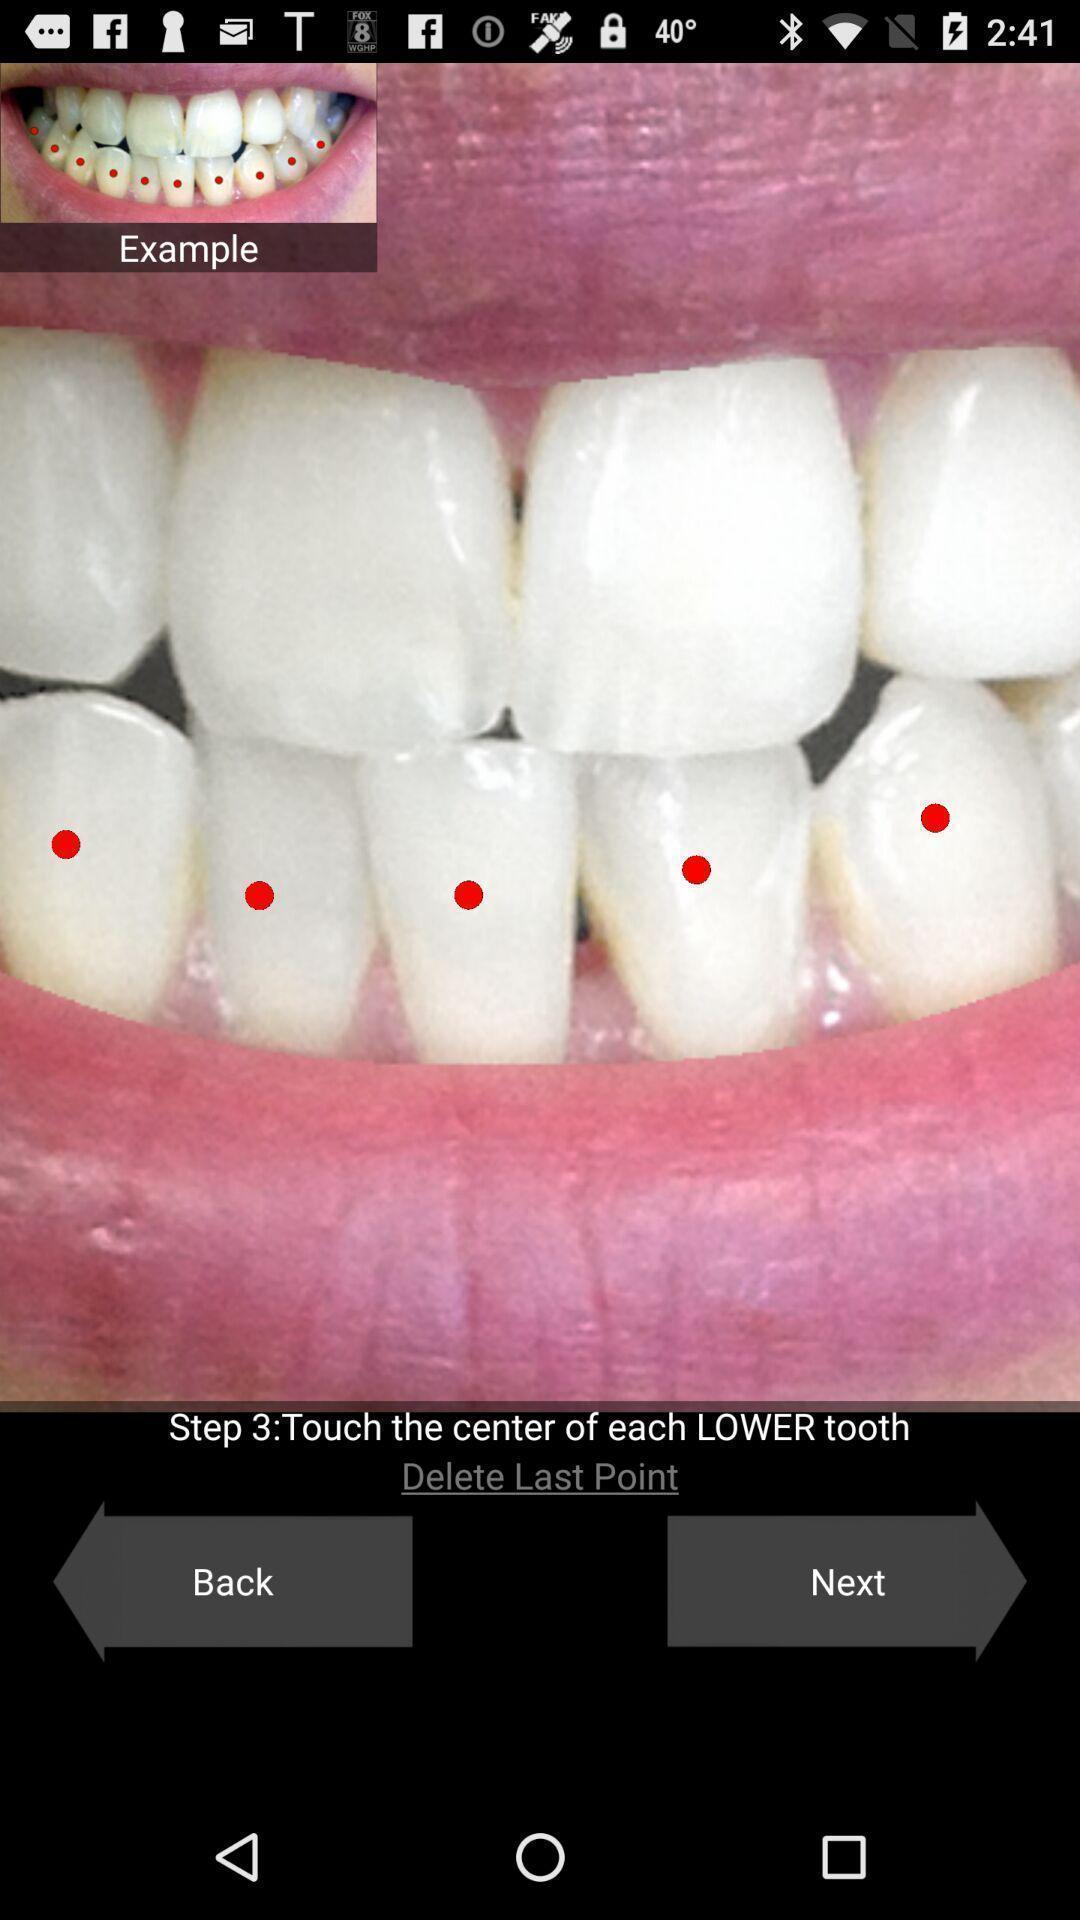Please provide a description for this image. Screen displaying step 3. 